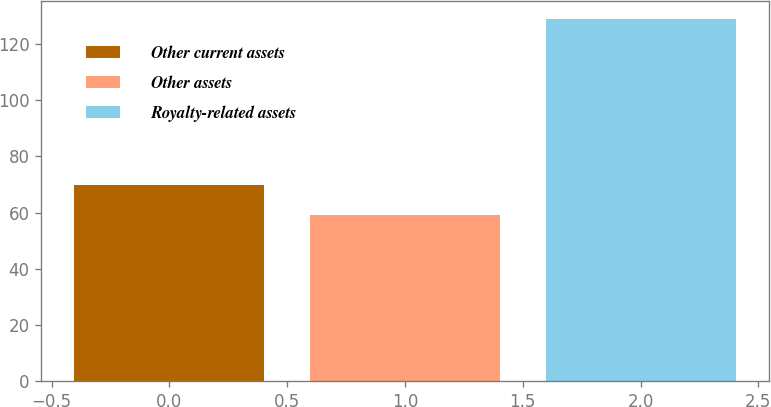Convert chart to OTSL. <chart><loc_0><loc_0><loc_500><loc_500><bar_chart><fcel>Other current assets<fcel>Other assets<fcel>Royalty-related assets<nl><fcel>70<fcel>59<fcel>129<nl></chart> 